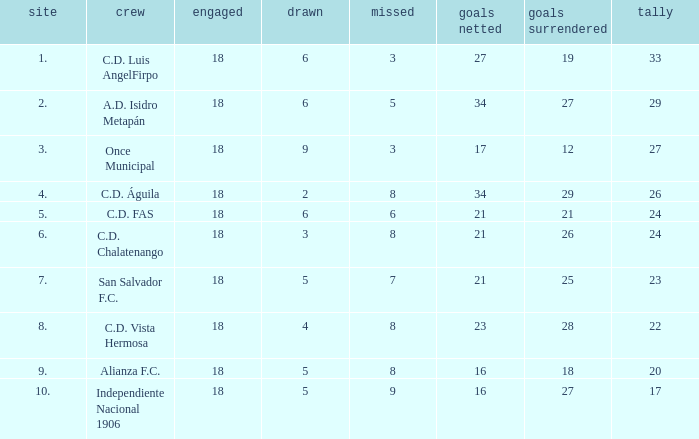How many points were in a game that had a lost of 5, greater than place 2, and 27 goals conceded? 0.0. Parse the full table. {'header': ['site', 'crew', 'engaged', 'drawn', 'missed', 'goals netted', 'goals surrendered', 'tally'], 'rows': [['1.', 'C.D. Luis AngelFirpo', '18', '6', '3', '27', '19', '33'], ['2.', 'A.D. Isidro Metapán', '18', '6', '5', '34', '27', '29'], ['3.', 'Once Municipal', '18', '9', '3', '17', '12', '27'], ['4.', 'C.D. Águila', '18', '2', '8', '34', '29', '26'], ['5.', 'C.D. FAS', '18', '6', '6', '21', '21', '24'], ['6.', 'C.D. Chalatenango', '18', '3', '8', '21', '26', '24'], ['7.', 'San Salvador F.C.', '18', '5', '7', '21', '25', '23'], ['8.', 'C.D. Vista Hermosa', '18', '4', '8', '23', '28', '22'], ['9.', 'Alianza F.C.', '18', '5', '8', '16', '18', '20'], ['10.', 'Independiente Nacional 1906', '18', '5', '9', '16', '27', '17']]} 